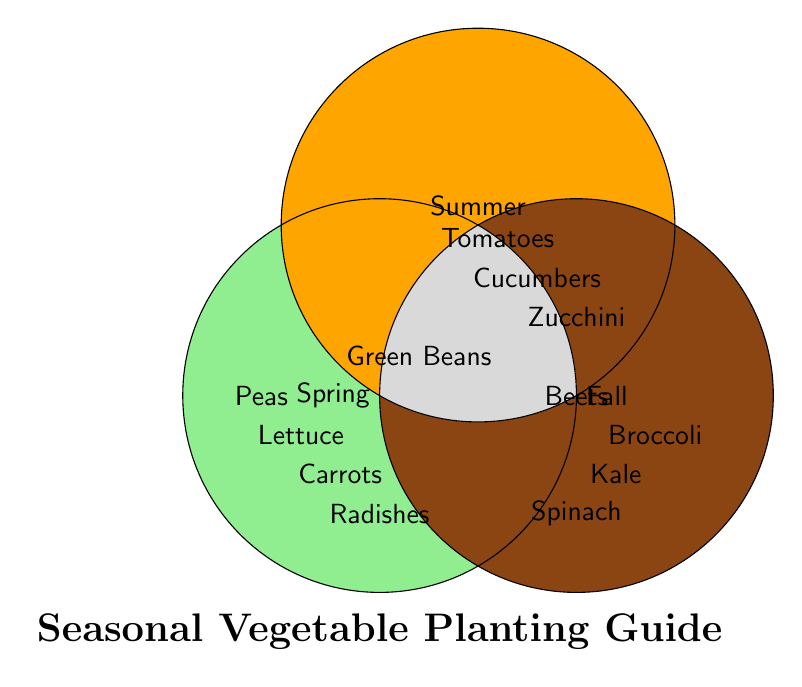How many vegetables are planted in Spring only? The 'Spring' circle has Peas, Lettuce, and Carrots, which are only in the Spring circle and not overlapped with other seasons.
Answer: 3 Which vegetable is planted in all three seasons? The vegetable located in the intersection of Spring, Summer, and Fall is Green Beans.
Answer: Green Beans Which vegetables are planted both in Spring and Summer, but not in Fall? The vegetables Radishes and Beets are in the overlapping region of Spring and Summer circles but not in the Fall circle.
Answer: Radishes and Beets What is the planting time for Tomatoes? Tomatoes are located in the Summer circle, and their planting time is listed as Late Spring.
Answer: Late Spring How many vegetables are planted in Summer only? The 'Summer' circle has Tomatoes, Cucumbers, and Zucchini, which are only in the Summer circle and not overlapped with other seasons.
Answer: 3 Name the vegetables that overlap between Summer and Fall. The vegetable Beets is located in the overlapping region of Summer and Fall.
Answer: Beets Which vegetables are specific to the Fall season? The 'Fall' circle lists Broccoli, Kale, and Spinach as Fall-specific vegetables.
Answer: Broccoli, Kale, and Spinach Are there more vegetables planted in only one season or in multiple seasons? There are 9 vegetables planted in only one season (Peas, Lettuce, Carrots, Tomatoes, Cucumbers, Zucchini, Broccoli, Kale, Spinach), and 3 vegetables planted in multiple seasons (Radishes, Beets, Green Beans). Thus, more vegetables are planted in only one season.
Answer: More are planted in only one season 